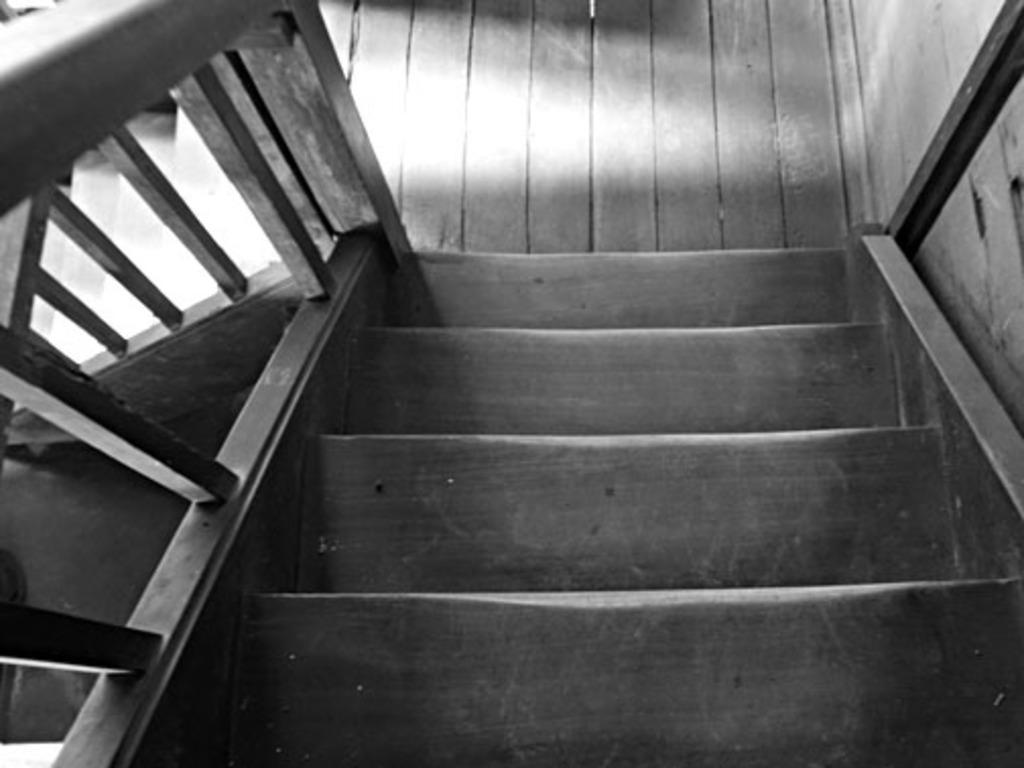Describe this image in one or two sentences. This is the picture of a wooden staircase to which there is a fencing. 